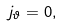Convert formula to latex. <formula><loc_0><loc_0><loc_500><loc_500>j _ { \vartheta } = 0 ,</formula> 